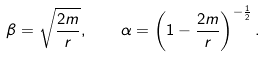<formula> <loc_0><loc_0><loc_500><loc_500>\beta = \sqrt { \frac { 2 m } r } , \quad \alpha = \left ( 1 - { \frac { 2 m } r } \right ) ^ { - { \frac { 1 } { 2 } } } .</formula> 